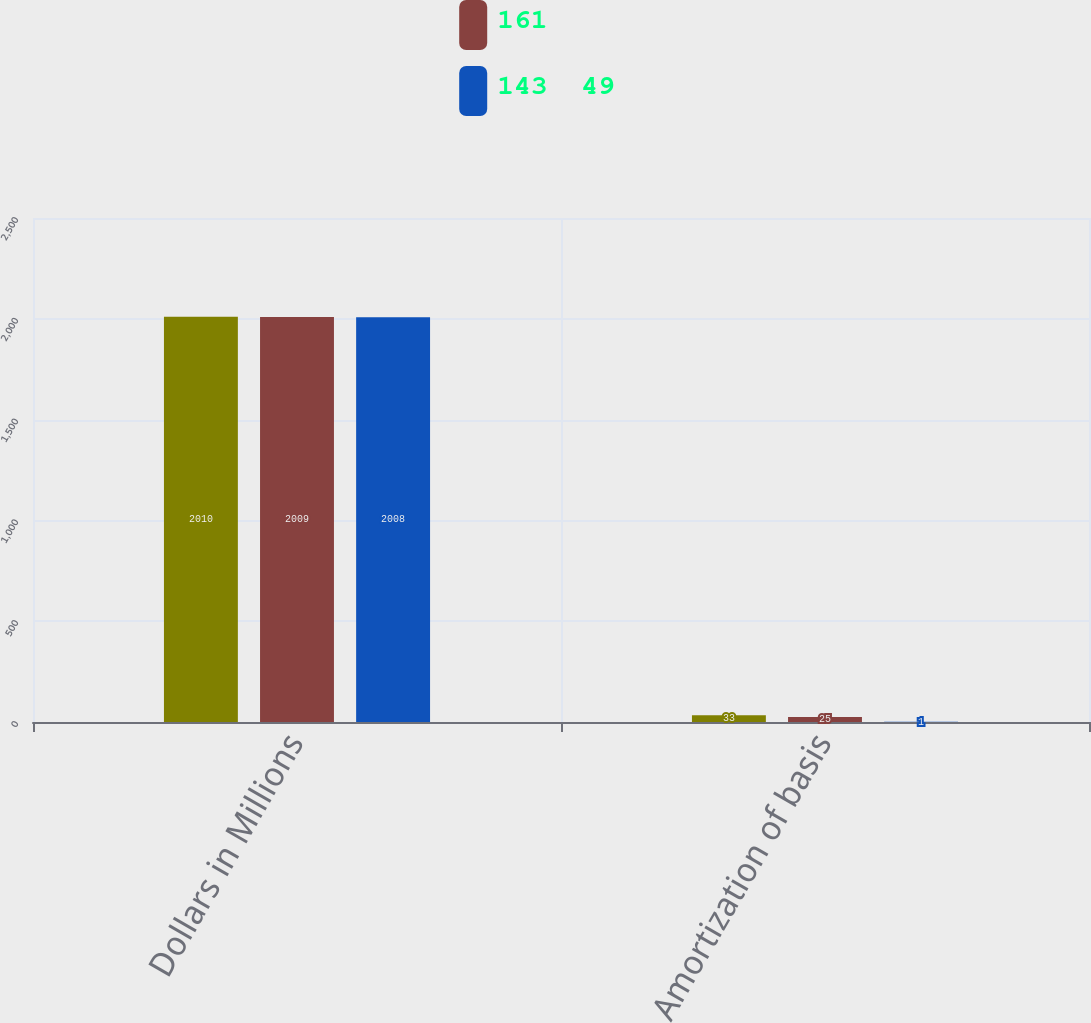Convert chart to OTSL. <chart><loc_0><loc_0><loc_500><loc_500><stacked_bar_chart><ecel><fcel>Dollars in Millions<fcel>Amortization of basis<nl><fcel>nan<fcel>2010<fcel>33<nl><fcel>161<fcel>2009<fcel>25<nl><fcel>143  49<fcel>2008<fcel>1<nl></chart> 